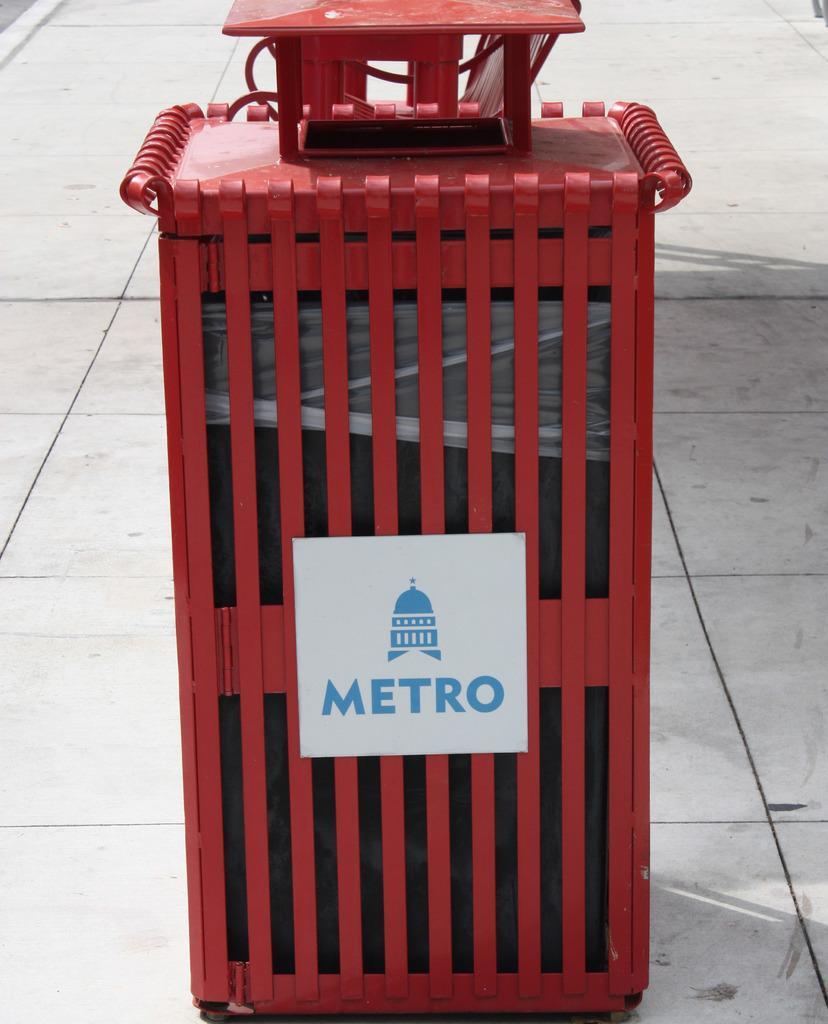In one or two sentences, can you explain what this image depicts? In the given image i can see a metal object and some text on it. 